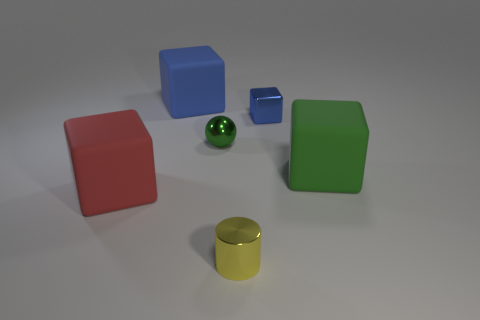There is a large thing that is the same color as the metallic ball; what is it made of?
Offer a terse response. Rubber. There is a small metallic ball; is its color the same as the metal object that is in front of the big red object?
Offer a very short reply. No. Is the number of large matte objects that are on the right side of the large red block greater than the number of big red rubber cubes?
Your answer should be compact. Yes. How many large matte blocks are in front of the matte cube behind the shiny object that is behind the small sphere?
Ensure brevity in your answer.  2. There is a big thing that is right of the small green metal thing; is its shape the same as the yellow shiny object?
Give a very brief answer. No. What is the object that is in front of the red rubber cube made of?
Make the answer very short. Metal. The big rubber thing that is both to the left of the cylinder and in front of the small blue object has what shape?
Offer a very short reply. Cube. What is the material of the red thing?
Your answer should be compact. Rubber. How many cylinders are either brown rubber objects or large green matte objects?
Provide a succinct answer. 0. Is the large red thing made of the same material as the tiny blue thing?
Offer a very short reply. No. 